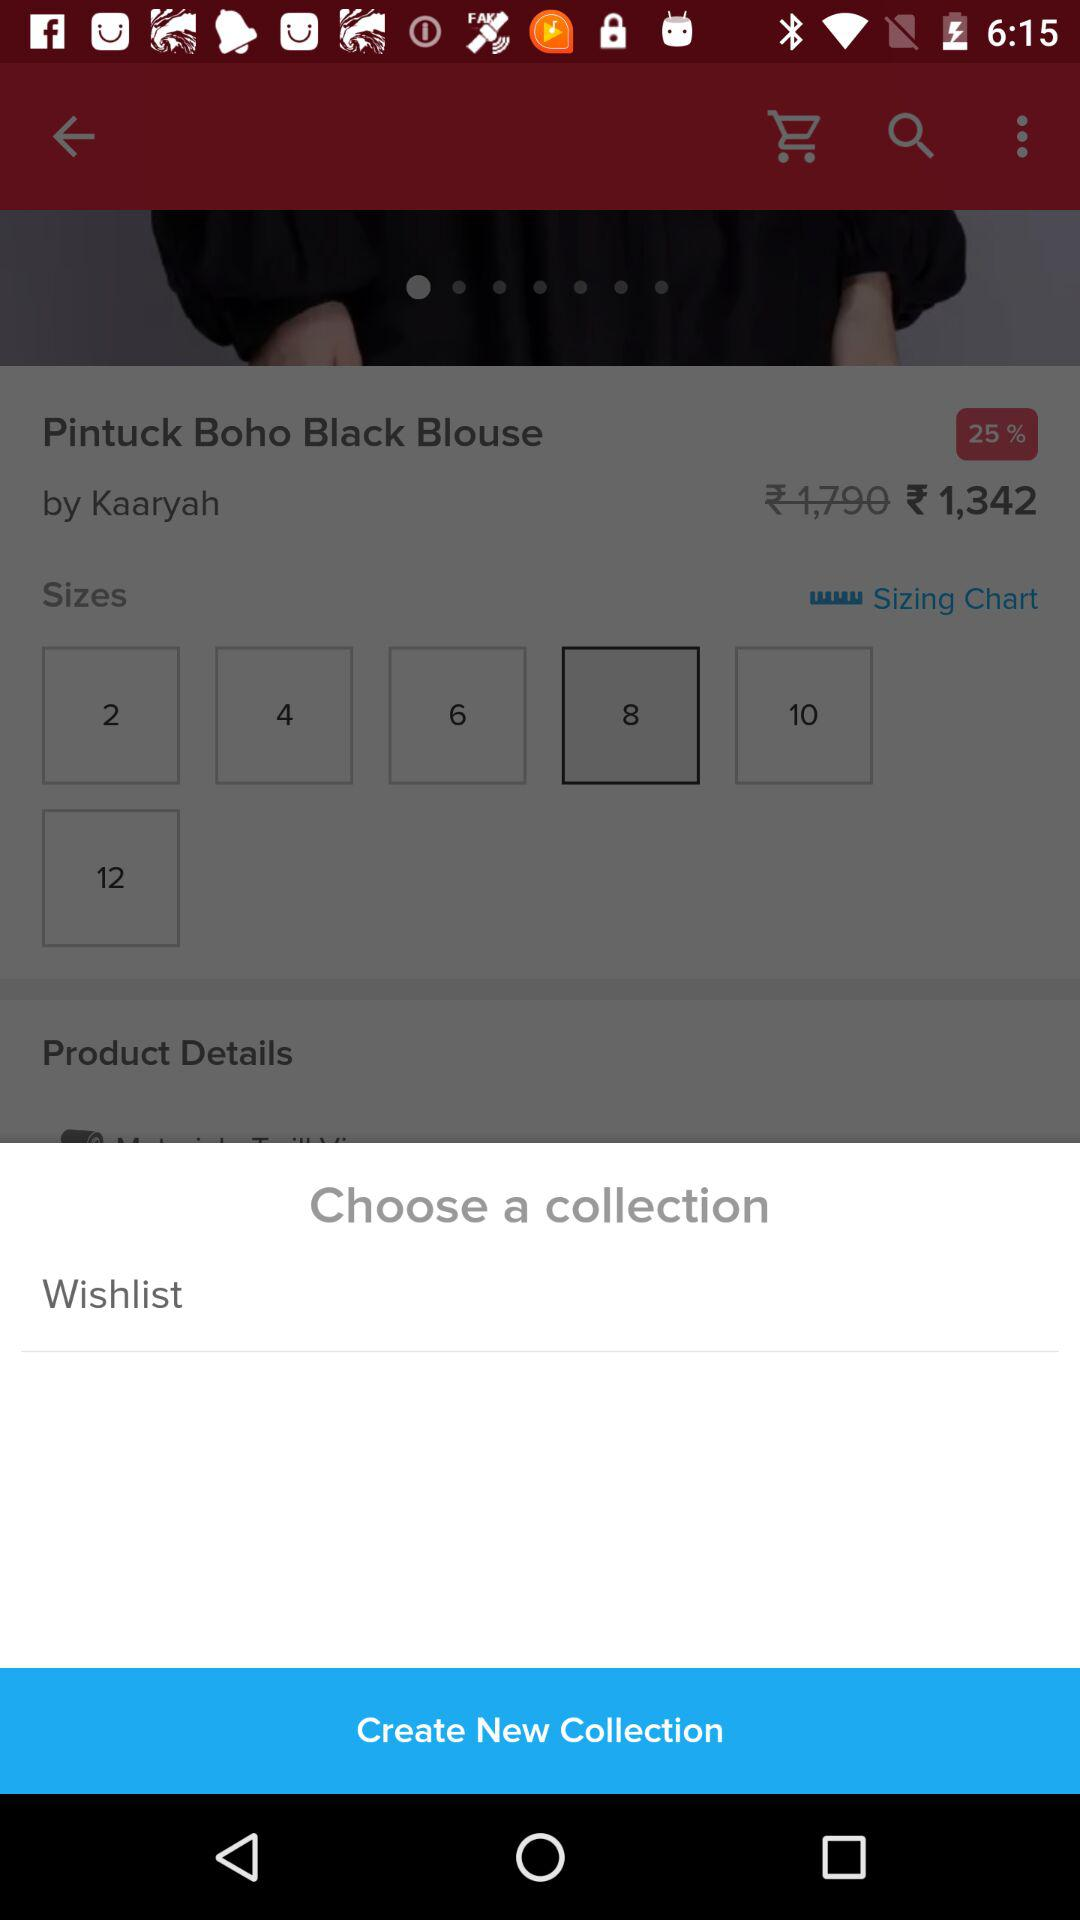What is the price of the Pintuck Boho Black Blouse? The price is ₹1,342. 